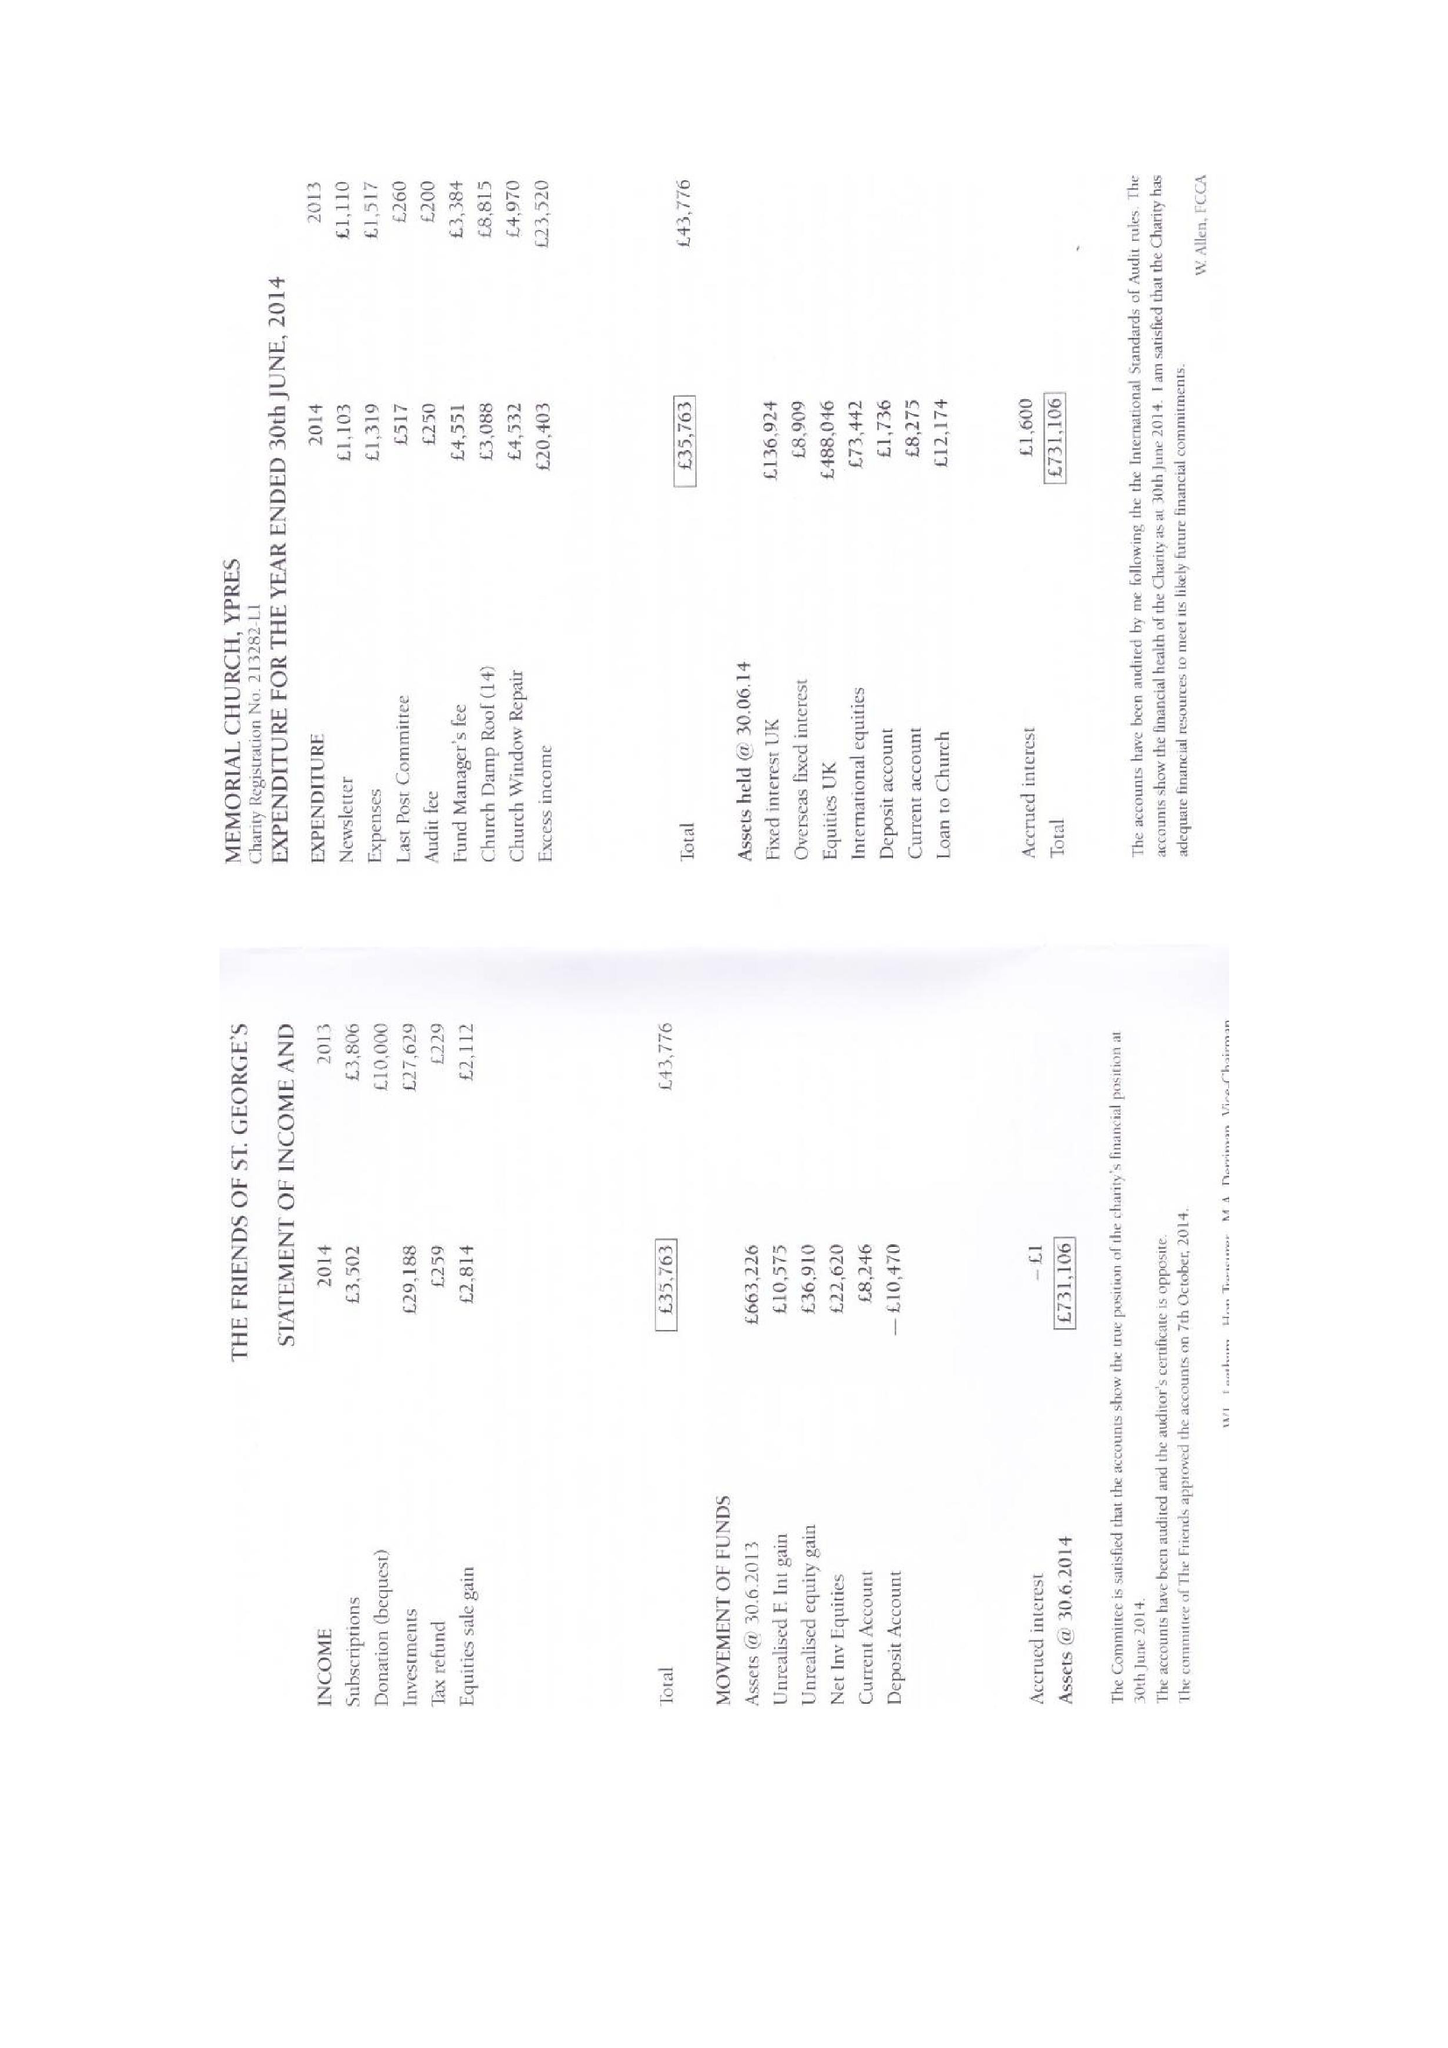What is the value for the address__post_town?
Answer the question using a single word or phrase. WHITSTABLE 